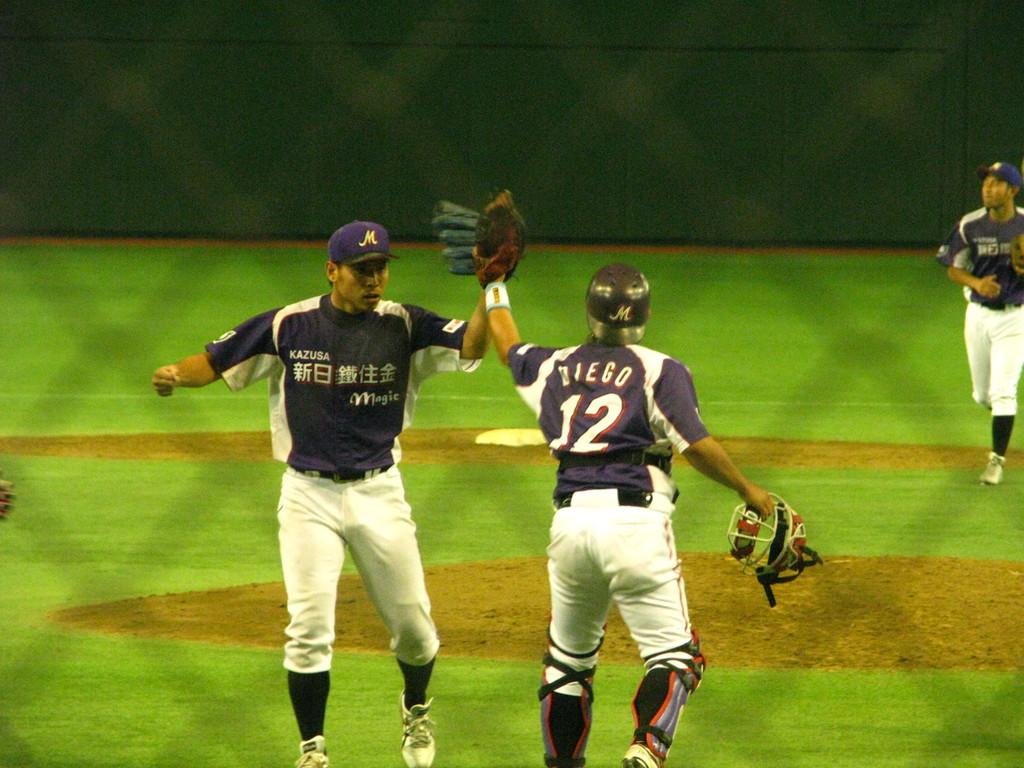What letter is on the baseball cap?
Provide a short and direct response. M. 